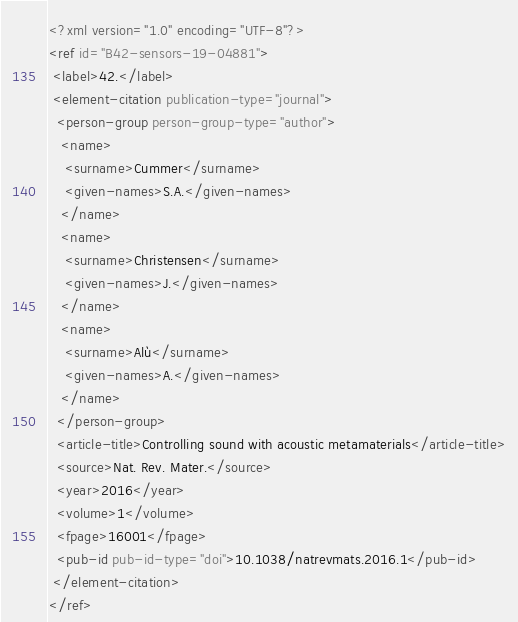Convert code to text. <code><loc_0><loc_0><loc_500><loc_500><_XML_><?xml version="1.0" encoding="UTF-8"?>
<ref id="B42-sensors-19-04881">
 <label>42.</label>
 <element-citation publication-type="journal">
  <person-group person-group-type="author">
   <name>
    <surname>Cummer</surname>
    <given-names>S.A.</given-names>
   </name>
   <name>
    <surname>Christensen</surname>
    <given-names>J.</given-names>
   </name>
   <name>
    <surname>Alù</surname>
    <given-names>A.</given-names>
   </name>
  </person-group>
  <article-title>Controlling sound with acoustic metamaterials</article-title>
  <source>Nat. Rev. Mater.</source>
  <year>2016</year>
  <volume>1</volume>
  <fpage>16001</fpage>
  <pub-id pub-id-type="doi">10.1038/natrevmats.2016.1</pub-id>
 </element-citation>
</ref>
</code> 